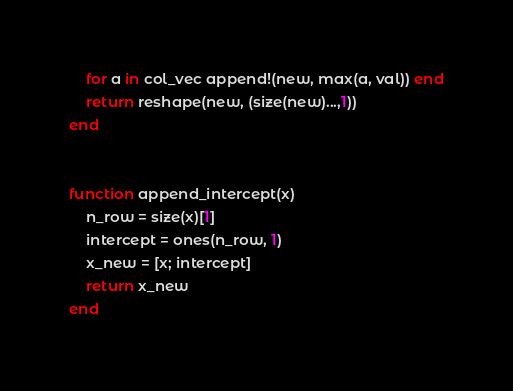<code> <loc_0><loc_0><loc_500><loc_500><_Julia_>    for a in col_vec append!(new, max(a, val)) end
    return reshape(new, (size(new)...,1))
end


function append_intercept(x)
    n_row = size(x)[1]
    intercept = ones(n_row, 1)
    x_new = [x; intercept]
    return x_new
end
</code> 